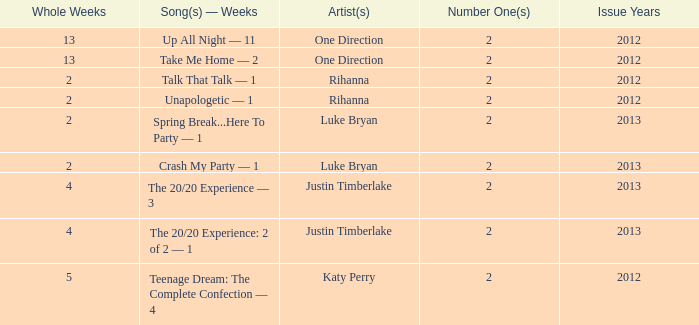What is the longest number of weeks any 1 song was at number #1? 13.0. Could you parse the entire table as a dict? {'header': ['Whole Weeks', 'Song(s) — Weeks', 'Artist(s)', 'Number One(s)', 'Issue Years'], 'rows': [['13', 'Up All Night — 11', 'One Direction', '2', '2012'], ['13', 'Take Me Home — 2', 'One Direction', '2', '2012'], ['2', 'Talk That Talk — 1', 'Rihanna', '2', '2012'], ['2', 'Unapologetic — 1', 'Rihanna', '2', '2012'], ['2', 'Spring Break...Here To Party — 1', 'Luke Bryan', '2', '2013'], ['2', 'Crash My Party — 1', 'Luke Bryan', '2', '2013'], ['4', 'The 20/20 Experience — 3', 'Justin Timberlake', '2', '2013'], ['4', 'The 20/20 Experience: 2 of 2 — 1', 'Justin Timberlake', '2', '2013'], ['5', 'Teenage Dream: The Complete Confection — 4', 'Katy Perry', '2', '2012']]} 